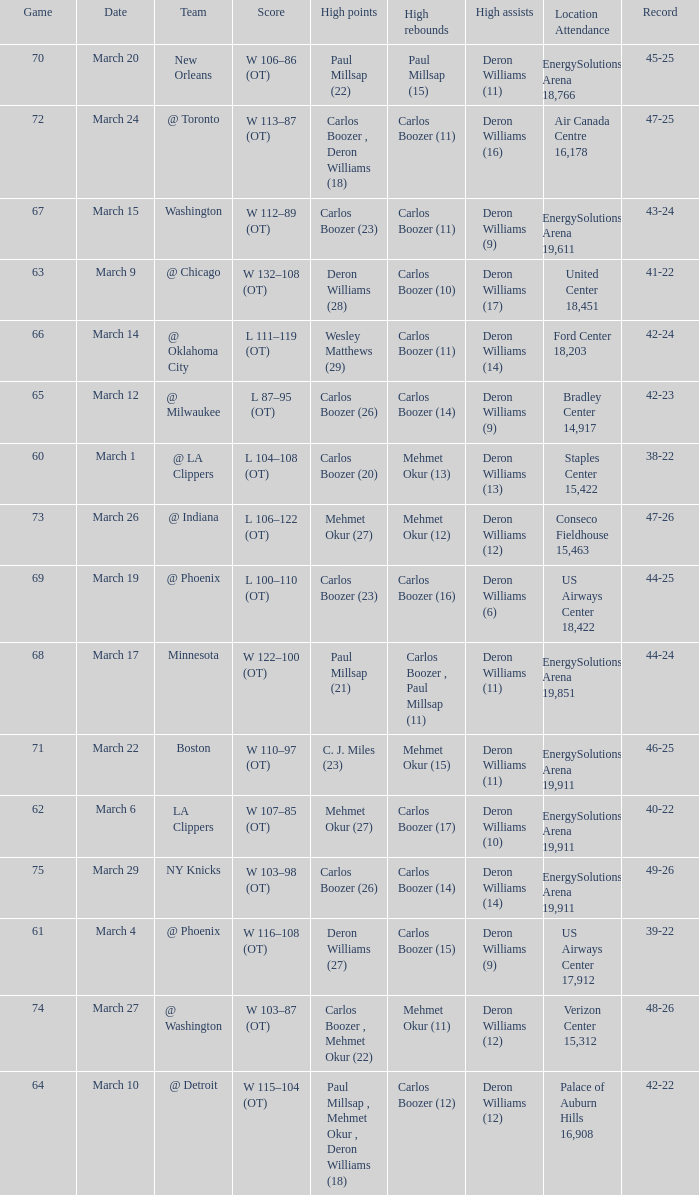How many different players did the most high assists on the March 4 game? 1.0. 